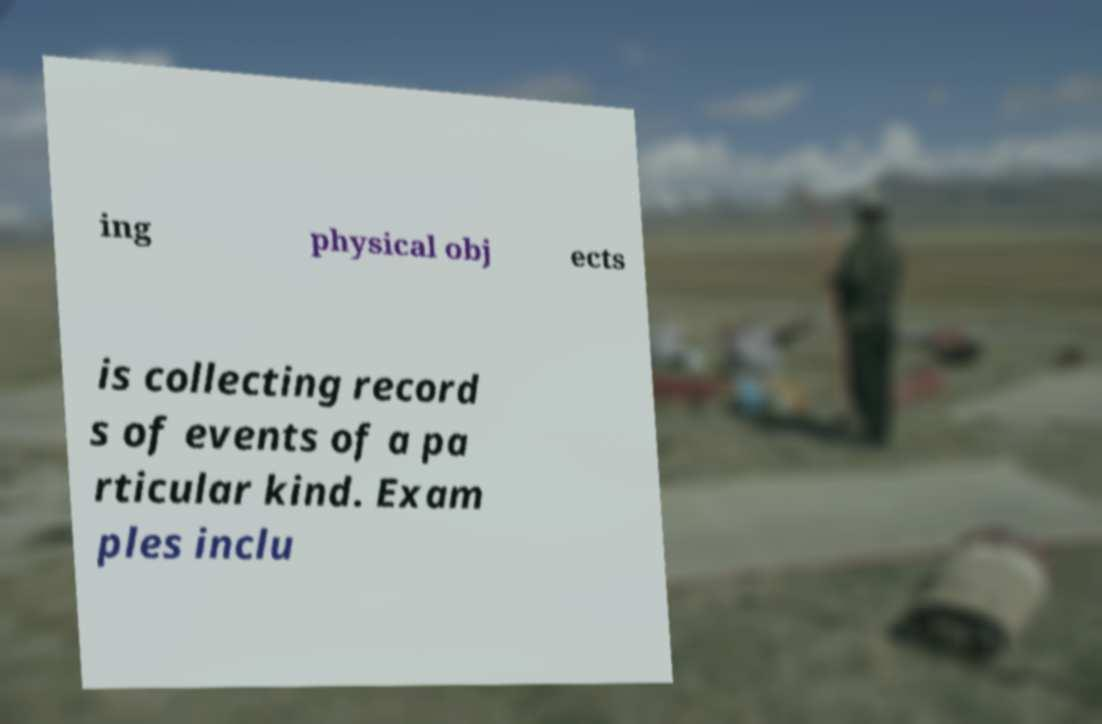Can you accurately transcribe the text from the provided image for me? ing physical obj ects is collecting record s of events of a pa rticular kind. Exam ples inclu 